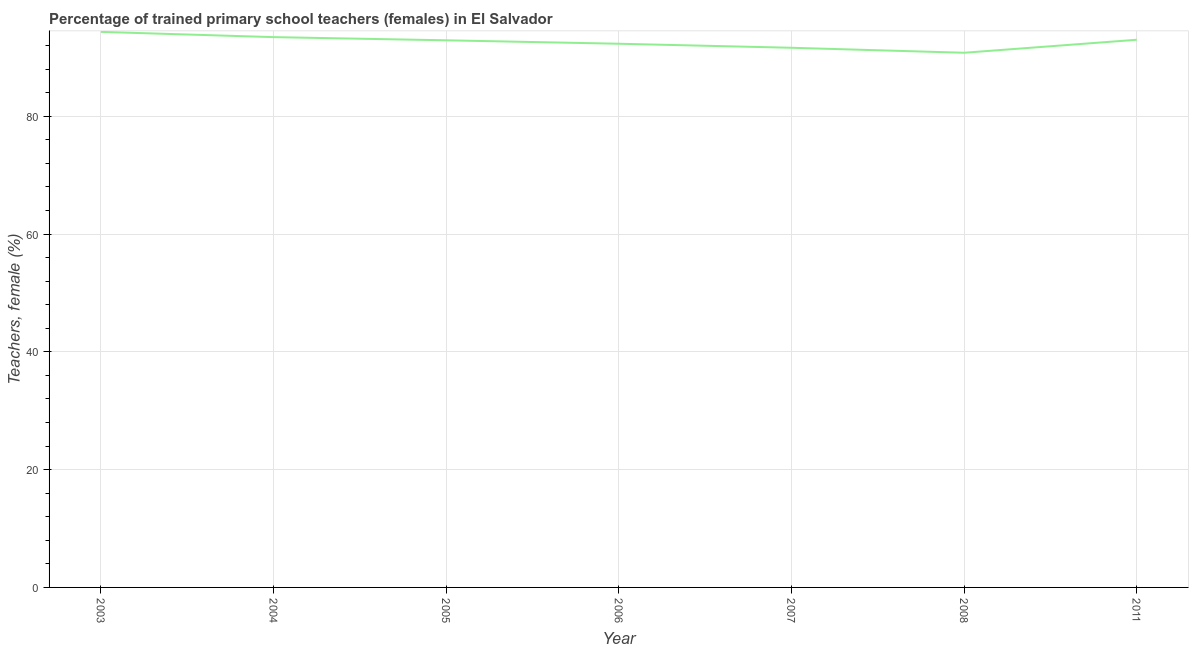What is the percentage of trained female teachers in 2003?
Provide a short and direct response. 94.32. Across all years, what is the maximum percentage of trained female teachers?
Offer a terse response. 94.32. Across all years, what is the minimum percentage of trained female teachers?
Make the answer very short. 90.77. What is the sum of the percentage of trained female teachers?
Provide a succinct answer. 648.29. What is the difference between the percentage of trained female teachers in 2004 and 2007?
Provide a succinct answer. 1.81. What is the average percentage of trained female teachers per year?
Provide a succinct answer. 92.61. What is the median percentage of trained female teachers?
Offer a very short reply. 92.89. What is the ratio of the percentage of trained female teachers in 2005 to that in 2006?
Offer a very short reply. 1.01. Is the percentage of trained female teachers in 2003 less than that in 2006?
Offer a very short reply. No. Is the difference between the percentage of trained female teachers in 2007 and 2008 greater than the difference between any two years?
Give a very brief answer. No. What is the difference between the highest and the second highest percentage of trained female teachers?
Your answer should be compact. 0.89. What is the difference between the highest and the lowest percentage of trained female teachers?
Provide a short and direct response. 3.55. In how many years, is the percentage of trained female teachers greater than the average percentage of trained female teachers taken over all years?
Make the answer very short. 4. Does the percentage of trained female teachers monotonically increase over the years?
Offer a very short reply. No. How many years are there in the graph?
Your answer should be very brief. 7. Does the graph contain any zero values?
Your answer should be very brief. No. Does the graph contain grids?
Your answer should be very brief. Yes. What is the title of the graph?
Keep it short and to the point. Percentage of trained primary school teachers (females) in El Salvador. What is the label or title of the X-axis?
Ensure brevity in your answer.  Year. What is the label or title of the Y-axis?
Offer a very short reply. Teachers, female (%). What is the Teachers, female (%) of 2003?
Your response must be concise. 94.32. What is the Teachers, female (%) in 2004?
Provide a succinct answer. 93.42. What is the Teachers, female (%) in 2005?
Your response must be concise. 92.89. What is the Teachers, female (%) in 2006?
Provide a succinct answer. 92.3. What is the Teachers, female (%) in 2007?
Offer a very short reply. 91.62. What is the Teachers, female (%) in 2008?
Your answer should be compact. 90.77. What is the Teachers, female (%) in 2011?
Offer a very short reply. 92.98. What is the difference between the Teachers, female (%) in 2003 and 2004?
Keep it short and to the point. 0.89. What is the difference between the Teachers, female (%) in 2003 and 2005?
Your answer should be compact. 1.43. What is the difference between the Teachers, female (%) in 2003 and 2006?
Your response must be concise. 2.01. What is the difference between the Teachers, female (%) in 2003 and 2007?
Your answer should be compact. 2.7. What is the difference between the Teachers, female (%) in 2003 and 2008?
Your answer should be very brief. 3.55. What is the difference between the Teachers, female (%) in 2003 and 2011?
Provide a succinct answer. 1.34. What is the difference between the Teachers, female (%) in 2004 and 2005?
Your answer should be compact. 0.54. What is the difference between the Teachers, female (%) in 2004 and 2006?
Your answer should be very brief. 1.12. What is the difference between the Teachers, female (%) in 2004 and 2007?
Make the answer very short. 1.81. What is the difference between the Teachers, female (%) in 2004 and 2008?
Provide a succinct answer. 2.65. What is the difference between the Teachers, female (%) in 2004 and 2011?
Offer a very short reply. 0.45. What is the difference between the Teachers, female (%) in 2005 and 2006?
Your answer should be very brief. 0.58. What is the difference between the Teachers, female (%) in 2005 and 2007?
Provide a succinct answer. 1.27. What is the difference between the Teachers, female (%) in 2005 and 2008?
Make the answer very short. 2.12. What is the difference between the Teachers, female (%) in 2005 and 2011?
Offer a terse response. -0.09. What is the difference between the Teachers, female (%) in 2006 and 2007?
Provide a short and direct response. 0.68. What is the difference between the Teachers, female (%) in 2006 and 2008?
Your answer should be very brief. 1.53. What is the difference between the Teachers, female (%) in 2006 and 2011?
Provide a short and direct response. -0.67. What is the difference between the Teachers, female (%) in 2007 and 2008?
Make the answer very short. 0.85. What is the difference between the Teachers, female (%) in 2007 and 2011?
Ensure brevity in your answer.  -1.36. What is the difference between the Teachers, female (%) in 2008 and 2011?
Offer a terse response. -2.21. What is the ratio of the Teachers, female (%) in 2003 to that in 2004?
Provide a short and direct response. 1.01. What is the ratio of the Teachers, female (%) in 2003 to that in 2005?
Provide a short and direct response. 1.01. What is the ratio of the Teachers, female (%) in 2003 to that in 2008?
Your answer should be compact. 1.04. What is the ratio of the Teachers, female (%) in 2004 to that in 2006?
Offer a very short reply. 1.01. What is the ratio of the Teachers, female (%) in 2004 to that in 2007?
Ensure brevity in your answer.  1.02. What is the ratio of the Teachers, female (%) in 2004 to that in 2011?
Offer a very short reply. 1. What is the ratio of the Teachers, female (%) in 2005 to that in 2006?
Ensure brevity in your answer.  1.01. What is the ratio of the Teachers, female (%) in 2005 to that in 2007?
Keep it short and to the point. 1.01. What is the ratio of the Teachers, female (%) in 2006 to that in 2008?
Keep it short and to the point. 1.02. What is the ratio of the Teachers, female (%) in 2007 to that in 2008?
Ensure brevity in your answer.  1.01. What is the ratio of the Teachers, female (%) in 2007 to that in 2011?
Make the answer very short. 0.98. 